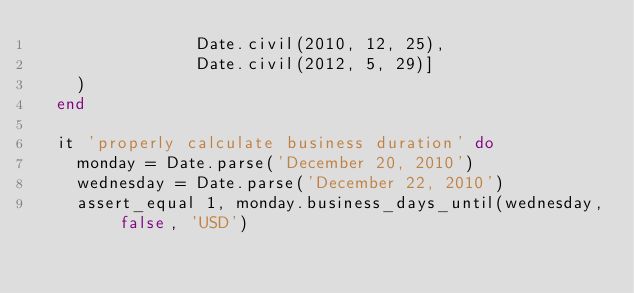<code> <loc_0><loc_0><loc_500><loc_500><_Ruby_>                Date.civil(2010, 12, 25),
                Date.civil(2012, 5, 29)]
    )
  end

  it 'properly calculate business duration' do
    monday = Date.parse('December 20, 2010')
    wednesday = Date.parse('December 22, 2010')
    assert_equal 1, monday.business_days_until(wednesday, false, 'USD')</code> 